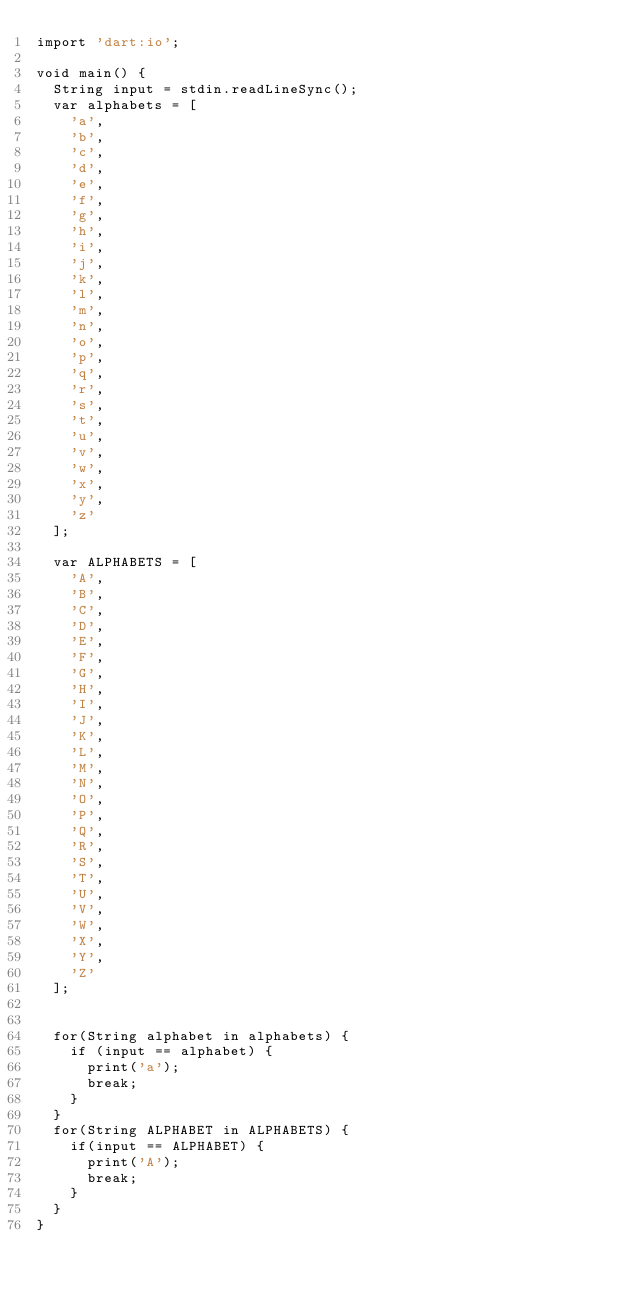<code> <loc_0><loc_0><loc_500><loc_500><_Dart_>import 'dart:io';

void main() {
  String input = stdin.readLineSync();
  var alphabets = [
    'a',
    'b',
    'c',
    'd',
    'e',
    'f',
    'g',
    'h',
    'i',
    'j',
    'k',
    'l',
    'm',
    'n',
    'o',
    'p',
    'q',
    'r',
    's',
    't',
    'u',
    'v',
    'w',
    'x',
    'y',
    'z'
  ];

  var ALPHABETS = [
    'A',
    'B',
    'C',
    'D',
    'E',
    'F',
    'G',
    'H',
    'I',
    'J',
    'K',
    'L',
    'M',
    'N',
    'O',
    'P',
    'Q',
    'R',
    'S',
    'T',
    'U',
    'V',
    'W',
    'X',
    'Y',
    'Z'
  ];

  
  for(String alphabet in alphabets) {
    if (input == alphabet) {
      print('a');
      break;
    }
  }
  for(String ALPHABET in ALPHABETS) {
    if(input == ALPHABET) {
      print('A');
      break;
    }
  }
}
</code> 